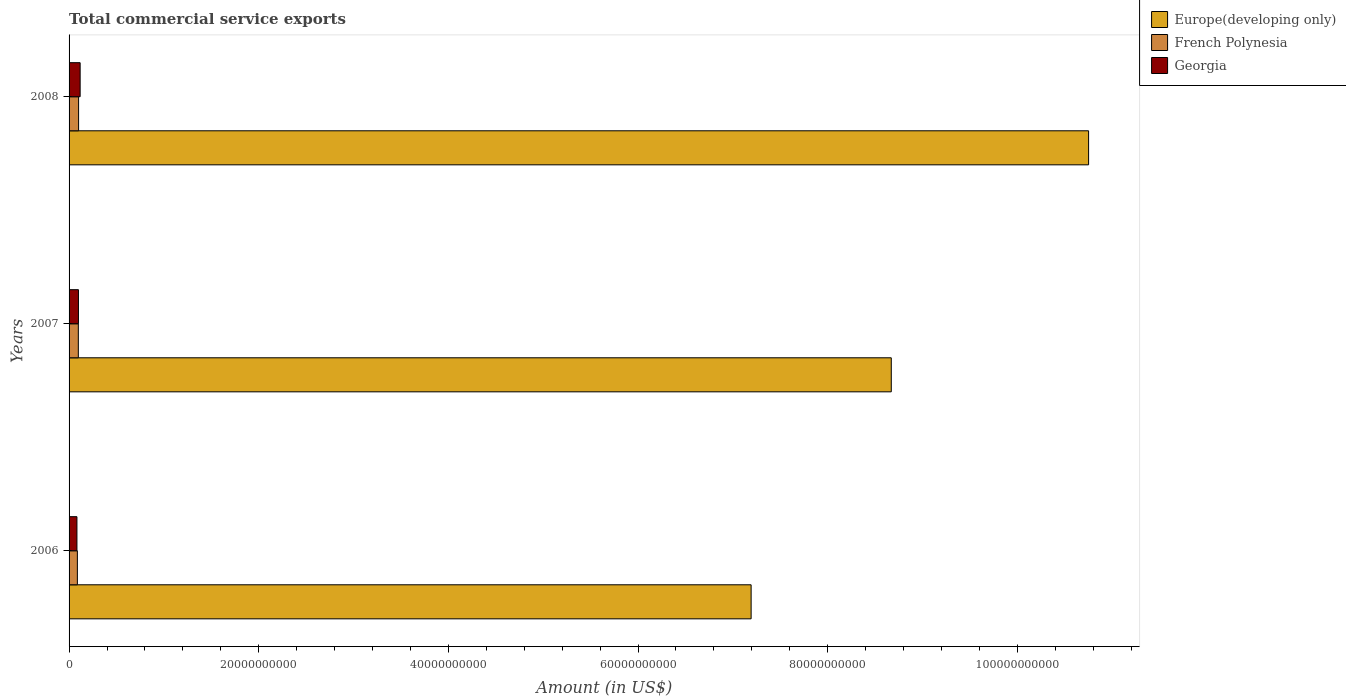Are the number of bars on each tick of the Y-axis equal?
Offer a terse response. Yes. How many bars are there on the 2nd tick from the top?
Make the answer very short. 3. How many bars are there on the 3rd tick from the bottom?
Your answer should be very brief. 3. What is the label of the 1st group of bars from the top?
Offer a very short reply. 2008. What is the total commercial service exports in Europe(developing only) in 2006?
Make the answer very short. 7.19e+1. Across all years, what is the maximum total commercial service exports in Europe(developing only)?
Make the answer very short. 1.08e+11. Across all years, what is the minimum total commercial service exports in French Polynesia?
Give a very brief answer. 8.76e+08. In which year was the total commercial service exports in Europe(developing only) maximum?
Ensure brevity in your answer.  2008. In which year was the total commercial service exports in French Polynesia minimum?
Your response must be concise. 2006. What is the total total commercial service exports in French Polynesia in the graph?
Offer a terse response. 2.86e+09. What is the difference between the total commercial service exports in Europe(developing only) in 2006 and that in 2007?
Keep it short and to the point. -1.48e+1. What is the difference between the total commercial service exports in French Polynesia in 2008 and the total commercial service exports in Europe(developing only) in 2007?
Provide a short and direct response. -8.57e+1. What is the average total commercial service exports in Georgia per year?
Ensure brevity in your answer.  9.95e+08. In the year 2008, what is the difference between the total commercial service exports in Georgia and total commercial service exports in Europe(developing only)?
Give a very brief answer. -1.06e+11. What is the ratio of the total commercial service exports in Georgia in 2007 to that in 2008?
Provide a succinct answer. 0.85. Is the total commercial service exports in Europe(developing only) in 2007 less than that in 2008?
Offer a very short reply. Yes. Is the difference between the total commercial service exports in Georgia in 2006 and 2008 greater than the difference between the total commercial service exports in Europe(developing only) in 2006 and 2008?
Provide a succinct answer. Yes. What is the difference between the highest and the second highest total commercial service exports in Europe(developing only)?
Keep it short and to the point. 2.08e+1. What is the difference between the highest and the lowest total commercial service exports in Europe(developing only)?
Keep it short and to the point. 3.56e+1. In how many years, is the total commercial service exports in Europe(developing only) greater than the average total commercial service exports in Europe(developing only) taken over all years?
Keep it short and to the point. 1. Is the sum of the total commercial service exports in French Polynesia in 2007 and 2008 greater than the maximum total commercial service exports in Europe(developing only) across all years?
Provide a succinct answer. No. What does the 1st bar from the top in 2006 represents?
Provide a succinct answer. Georgia. What does the 1st bar from the bottom in 2008 represents?
Your answer should be compact. Europe(developing only). How many years are there in the graph?
Keep it short and to the point. 3. Does the graph contain any zero values?
Ensure brevity in your answer.  No. Does the graph contain grids?
Keep it short and to the point. No. Where does the legend appear in the graph?
Provide a short and direct response. Top right. How are the legend labels stacked?
Your response must be concise. Vertical. What is the title of the graph?
Your answer should be very brief. Total commercial service exports. What is the Amount (in US$) in Europe(developing only) in 2006?
Offer a terse response. 7.19e+1. What is the Amount (in US$) of French Polynesia in 2006?
Provide a short and direct response. 8.76e+08. What is the Amount (in US$) of Georgia in 2006?
Ensure brevity in your answer.  8.29e+08. What is the Amount (in US$) of Europe(developing only) in 2007?
Your response must be concise. 8.67e+1. What is the Amount (in US$) in French Polynesia in 2007?
Make the answer very short. 9.77e+08. What is the Amount (in US$) in Georgia in 2007?
Your response must be concise. 9.89e+08. What is the Amount (in US$) of Europe(developing only) in 2008?
Offer a terse response. 1.08e+11. What is the Amount (in US$) in French Polynesia in 2008?
Provide a short and direct response. 1.00e+09. What is the Amount (in US$) of Georgia in 2008?
Your response must be concise. 1.17e+09. Across all years, what is the maximum Amount (in US$) in Europe(developing only)?
Keep it short and to the point. 1.08e+11. Across all years, what is the maximum Amount (in US$) in French Polynesia?
Offer a very short reply. 1.00e+09. Across all years, what is the maximum Amount (in US$) in Georgia?
Your answer should be compact. 1.17e+09. Across all years, what is the minimum Amount (in US$) in Europe(developing only)?
Offer a very short reply. 7.19e+1. Across all years, what is the minimum Amount (in US$) of French Polynesia?
Make the answer very short. 8.76e+08. Across all years, what is the minimum Amount (in US$) of Georgia?
Ensure brevity in your answer.  8.29e+08. What is the total Amount (in US$) in Europe(developing only) in the graph?
Your answer should be very brief. 2.66e+11. What is the total Amount (in US$) in French Polynesia in the graph?
Your answer should be compact. 2.86e+09. What is the total Amount (in US$) of Georgia in the graph?
Your answer should be compact. 2.99e+09. What is the difference between the Amount (in US$) of Europe(developing only) in 2006 and that in 2007?
Give a very brief answer. -1.48e+1. What is the difference between the Amount (in US$) in French Polynesia in 2006 and that in 2007?
Provide a succinct answer. -1.01e+08. What is the difference between the Amount (in US$) in Georgia in 2006 and that in 2007?
Your response must be concise. -1.60e+08. What is the difference between the Amount (in US$) of Europe(developing only) in 2006 and that in 2008?
Your answer should be very brief. -3.56e+1. What is the difference between the Amount (in US$) in French Polynesia in 2006 and that in 2008?
Make the answer very short. -1.28e+08. What is the difference between the Amount (in US$) in Georgia in 2006 and that in 2008?
Make the answer very short. -3.38e+08. What is the difference between the Amount (in US$) in Europe(developing only) in 2007 and that in 2008?
Offer a terse response. -2.08e+1. What is the difference between the Amount (in US$) in French Polynesia in 2007 and that in 2008?
Give a very brief answer. -2.65e+07. What is the difference between the Amount (in US$) in Georgia in 2007 and that in 2008?
Provide a short and direct response. -1.78e+08. What is the difference between the Amount (in US$) of Europe(developing only) in 2006 and the Amount (in US$) of French Polynesia in 2007?
Give a very brief answer. 7.10e+1. What is the difference between the Amount (in US$) in Europe(developing only) in 2006 and the Amount (in US$) in Georgia in 2007?
Your answer should be compact. 7.09e+1. What is the difference between the Amount (in US$) in French Polynesia in 2006 and the Amount (in US$) in Georgia in 2007?
Keep it short and to the point. -1.13e+08. What is the difference between the Amount (in US$) of Europe(developing only) in 2006 and the Amount (in US$) of French Polynesia in 2008?
Ensure brevity in your answer.  7.09e+1. What is the difference between the Amount (in US$) of Europe(developing only) in 2006 and the Amount (in US$) of Georgia in 2008?
Make the answer very short. 7.08e+1. What is the difference between the Amount (in US$) of French Polynesia in 2006 and the Amount (in US$) of Georgia in 2008?
Give a very brief answer. -2.91e+08. What is the difference between the Amount (in US$) of Europe(developing only) in 2007 and the Amount (in US$) of French Polynesia in 2008?
Your response must be concise. 8.57e+1. What is the difference between the Amount (in US$) in Europe(developing only) in 2007 and the Amount (in US$) in Georgia in 2008?
Offer a terse response. 8.55e+1. What is the difference between the Amount (in US$) in French Polynesia in 2007 and the Amount (in US$) in Georgia in 2008?
Offer a very short reply. -1.90e+08. What is the average Amount (in US$) of Europe(developing only) per year?
Provide a short and direct response. 8.87e+1. What is the average Amount (in US$) of French Polynesia per year?
Your answer should be very brief. 9.52e+08. What is the average Amount (in US$) in Georgia per year?
Your response must be concise. 9.95e+08. In the year 2006, what is the difference between the Amount (in US$) in Europe(developing only) and Amount (in US$) in French Polynesia?
Your response must be concise. 7.11e+1. In the year 2006, what is the difference between the Amount (in US$) in Europe(developing only) and Amount (in US$) in Georgia?
Ensure brevity in your answer.  7.11e+1. In the year 2006, what is the difference between the Amount (in US$) of French Polynesia and Amount (in US$) of Georgia?
Your response must be concise. 4.66e+07. In the year 2007, what is the difference between the Amount (in US$) of Europe(developing only) and Amount (in US$) of French Polynesia?
Provide a succinct answer. 8.57e+1. In the year 2007, what is the difference between the Amount (in US$) of Europe(developing only) and Amount (in US$) of Georgia?
Your answer should be very brief. 8.57e+1. In the year 2007, what is the difference between the Amount (in US$) in French Polynesia and Amount (in US$) in Georgia?
Keep it short and to the point. -1.20e+07. In the year 2008, what is the difference between the Amount (in US$) in Europe(developing only) and Amount (in US$) in French Polynesia?
Your answer should be very brief. 1.07e+11. In the year 2008, what is the difference between the Amount (in US$) in Europe(developing only) and Amount (in US$) in Georgia?
Keep it short and to the point. 1.06e+11. In the year 2008, what is the difference between the Amount (in US$) of French Polynesia and Amount (in US$) of Georgia?
Offer a very short reply. -1.63e+08. What is the ratio of the Amount (in US$) of Europe(developing only) in 2006 to that in 2007?
Make the answer very short. 0.83. What is the ratio of the Amount (in US$) in French Polynesia in 2006 to that in 2007?
Keep it short and to the point. 0.9. What is the ratio of the Amount (in US$) in Georgia in 2006 to that in 2007?
Your response must be concise. 0.84. What is the ratio of the Amount (in US$) in Europe(developing only) in 2006 to that in 2008?
Your answer should be compact. 0.67. What is the ratio of the Amount (in US$) in French Polynesia in 2006 to that in 2008?
Provide a short and direct response. 0.87. What is the ratio of the Amount (in US$) in Georgia in 2006 to that in 2008?
Offer a terse response. 0.71. What is the ratio of the Amount (in US$) of Europe(developing only) in 2007 to that in 2008?
Keep it short and to the point. 0.81. What is the ratio of the Amount (in US$) in French Polynesia in 2007 to that in 2008?
Keep it short and to the point. 0.97. What is the ratio of the Amount (in US$) in Georgia in 2007 to that in 2008?
Keep it short and to the point. 0.85. What is the difference between the highest and the second highest Amount (in US$) of Europe(developing only)?
Make the answer very short. 2.08e+1. What is the difference between the highest and the second highest Amount (in US$) in French Polynesia?
Provide a succinct answer. 2.65e+07. What is the difference between the highest and the second highest Amount (in US$) in Georgia?
Provide a succinct answer. 1.78e+08. What is the difference between the highest and the lowest Amount (in US$) in Europe(developing only)?
Make the answer very short. 3.56e+1. What is the difference between the highest and the lowest Amount (in US$) of French Polynesia?
Your answer should be compact. 1.28e+08. What is the difference between the highest and the lowest Amount (in US$) in Georgia?
Your answer should be very brief. 3.38e+08. 